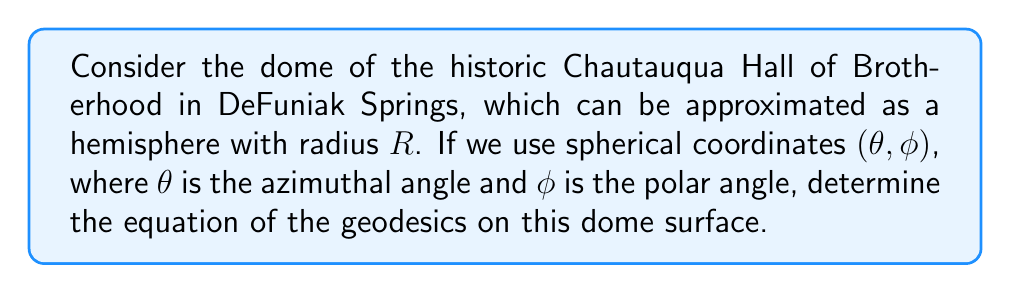Help me with this question. To find the geodesics on the dome surface, we'll follow these steps:

1) The metric for a sphere of radius $R$ in spherical coordinates is:

   $$ds^2 = R^2(d\phi^2 + \sin^2\phi d\theta^2)$$

2) The Lagrangian for this system is:

   $$L = R^2(\dot{\phi}^2 + \sin^2\phi \dot{\theta}^2)$$

   where dots represent derivatives with respect to some parameter $s$.

3) Since $\theta$ is cyclic (doesn't appear explicitly in $L$), we have a conserved quantity:

   $$\frac{\partial L}{\partial \dot{\theta}} = 2R^2\sin^2\phi \dot{\theta} = \text{constant} = c$$

4) This gives us:

   $$\dot{\theta} = \frac{c}{2R^2\sin^2\phi}$$

5) The equation of geodesics can be derived from this:

   $$\frac{d\theta}{d\phi} = \frac{\dot{\theta}}{\dot{\phi}} = \frac{c}{2R^2\sin^2\phi \dot{\phi}}$$

6) Integrating both sides:

   $$\int d\theta = \int \frac{c}{2R^2\sin^2\phi \dot{\phi}} d\phi$$

7) This results in:

   $$\theta = \pm \arccos(\sin\phi \cos\alpha) + \beta$$

   where $\alpha$ and $\beta$ are constants of integration.

This equation describes great circles on the sphere, which are the geodesics for a spherical surface.
Answer: $\theta = \pm \arccos(\sin\phi \cos\alpha) + \beta$, where $\alpha$ and $\beta$ are constants. 